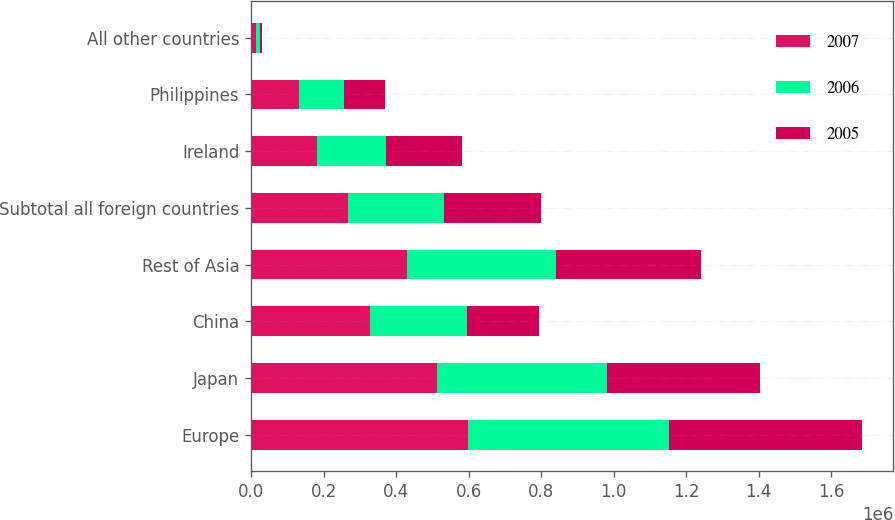Convert chart to OTSL. <chart><loc_0><loc_0><loc_500><loc_500><stacked_bar_chart><ecel><fcel>Europe<fcel>Japan<fcel>China<fcel>Rest of Asia<fcel>Subtotal all foreign countries<fcel>Ireland<fcel>Philippines<fcel>All other countries<nl><fcel>2007<fcel>599288<fcel>511488<fcel>328073<fcel>429181<fcel>266425<fcel>183075<fcel>133388<fcel>14206<nl><fcel>2006<fcel>554046<fcel>468967<fcel>266425<fcel>410415<fcel>266425<fcel>190050<fcel>123786<fcel>9586<nl><fcel>2005<fcel>532456<fcel>423220<fcel>199796<fcel>400257<fcel>266425<fcel>209205<fcel>112245<fcel>6532<nl></chart> 